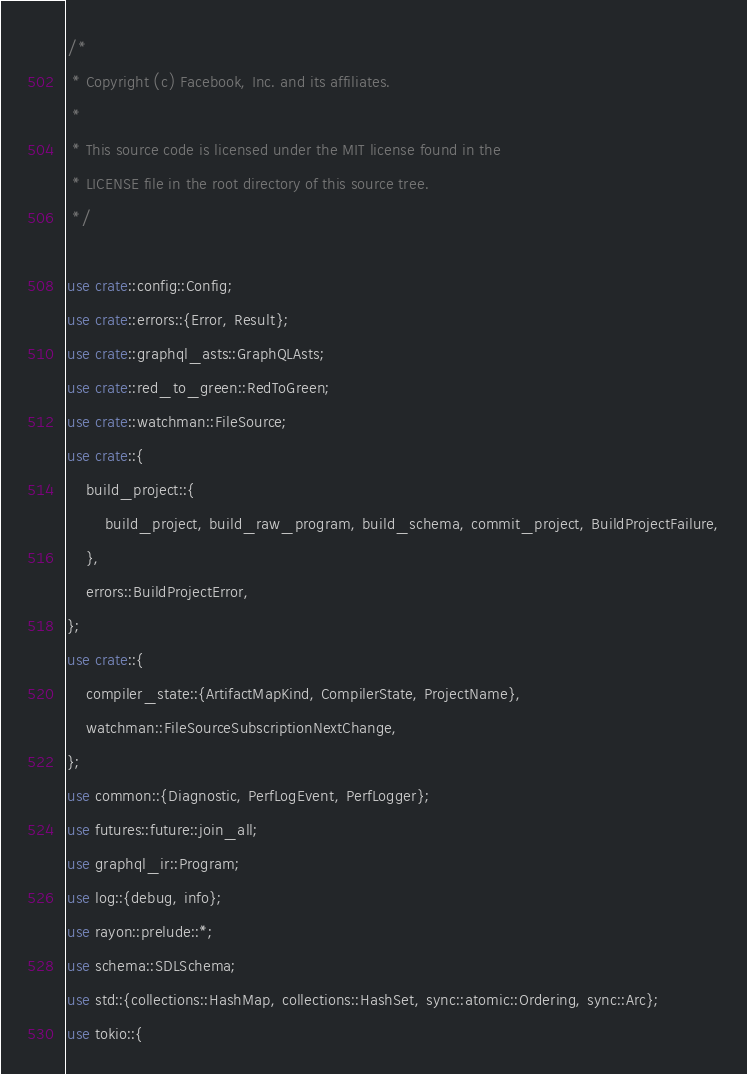Convert code to text. <code><loc_0><loc_0><loc_500><loc_500><_Rust_>/*
 * Copyright (c) Facebook, Inc. and its affiliates.
 *
 * This source code is licensed under the MIT license found in the
 * LICENSE file in the root directory of this source tree.
 */

use crate::config::Config;
use crate::errors::{Error, Result};
use crate::graphql_asts::GraphQLAsts;
use crate::red_to_green::RedToGreen;
use crate::watchman::FileSource;
use crate::{
    build_project::{
        build_project, build_raw_program, build_schema, commit_project, BuildProjectFailure,
    },
    errors::BuildProjectError,
};
use crate::{
    compiler_state::{ArtifactMapKind, CompilerState, ProjectName},
    watchman::FileSourceSubscriptionNextChange,
};
use common::{Diagnostic, PerfLogEvent, PerfLogger};
use futures::future::join_all;
use graphql_ir::Program;
use log::{debug, info};
use rayon::prelude::*;
use schema::SDLSchema;
use std::{collections::HashMap, collections::HashSet, sync::atomic::Ordering, sync::Arc};
use tokio::{</code> 